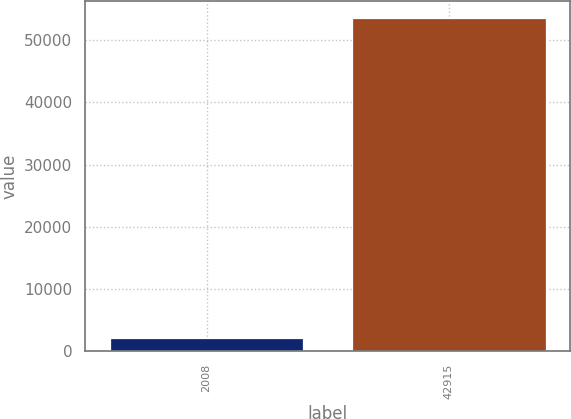Convert chart. <chart><loc_0><loc_0><loc_500><loc_500><bar_chart><fcel>2008<fcel>42915<nl><fcel>2007<fcel>53620<nl></chart> 